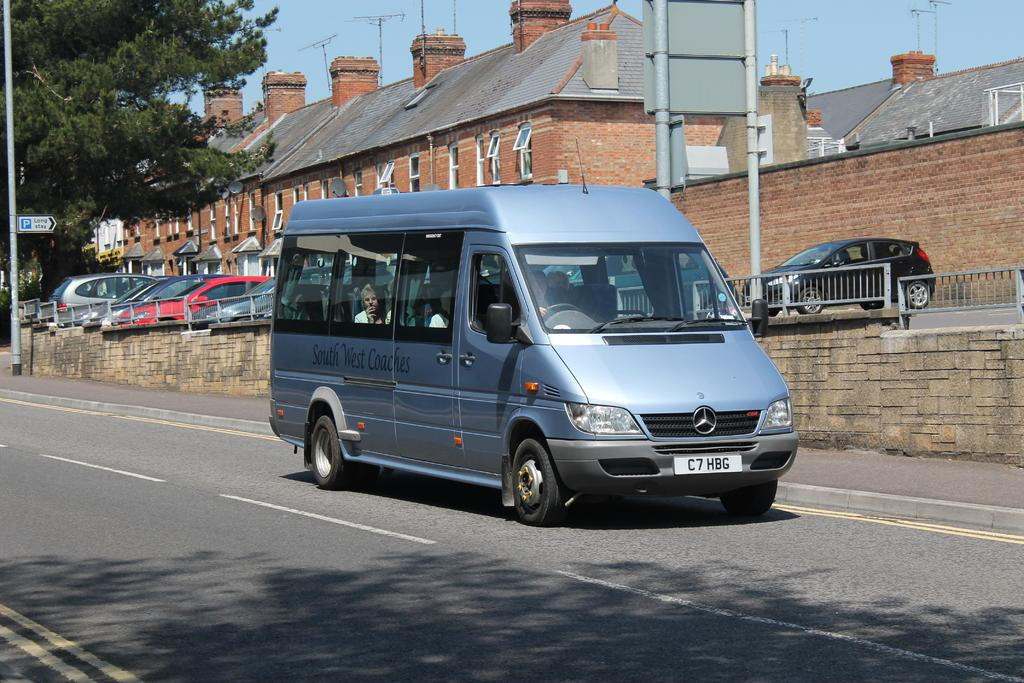<image>
Summarize the visual content of the image. A large blue Mercedes van with the license plate C7HBG. 